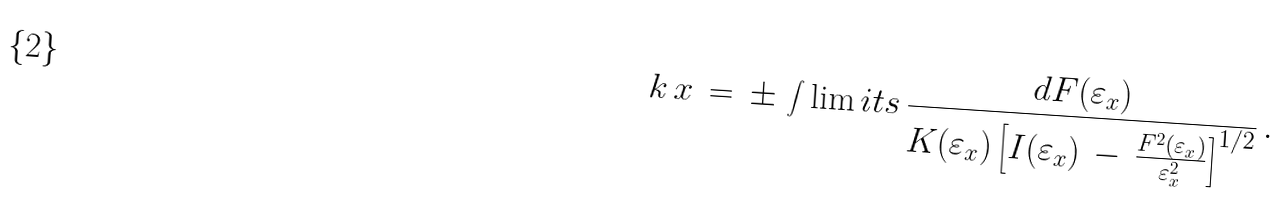<formula> <loc_0><loc_0><loc_500><loc_500>k \, x \, = \, \pm \, \int \lim i t s \, \frac { d F ( \varepsilon _ { x } ) } { K ( \varepsilon _ { x } ) \left [ I ( \varepsilon _ { x } ) \, - \, \frac { F ^ { 2 } ( \varepsilon _ { x } ) } { \varepsilon _ { x } ^ { 2 } } \right ] ^ { 1 / 2 } } \, .</formula> 